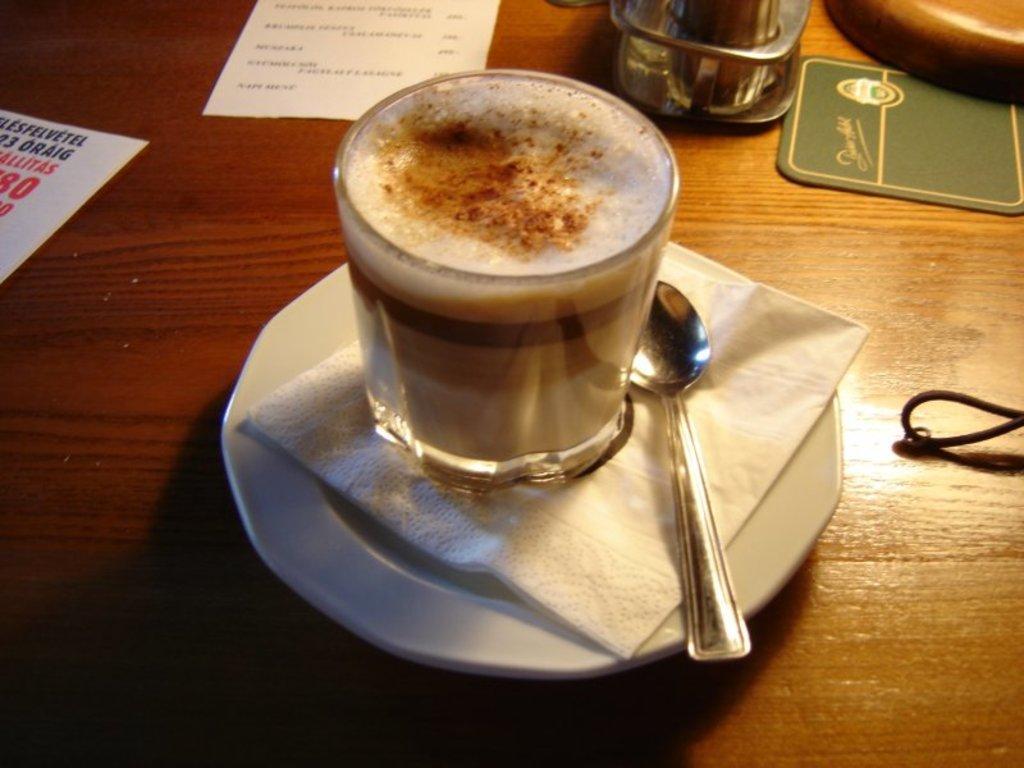In one or two sentences, can you explain what this image depicts? In this image, we can see a glass with liquid is placed on the tissue. Beside the glass, there is a spoon. Here we can see white saucer is placed on the wooden surface. Top of the image, we can see so many things and objects are placed on the wooden surface. 